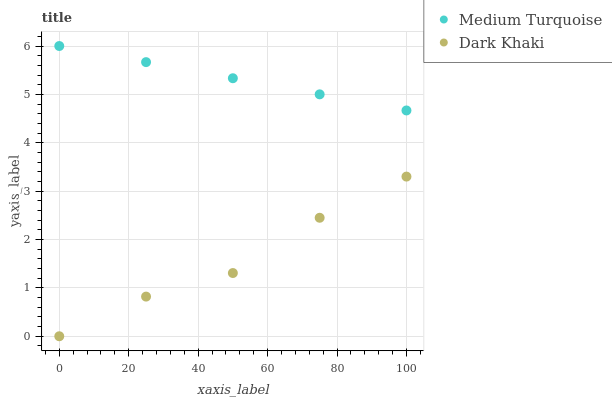Does Dark Khaki have the minimum area under the curve?
Answer yes or no. Yes. Does Medium Turquoise have the maximum area under the curve?
Answer yes or no. Yes. Does Medium Turquoise have the minimum area under the curve?
Answer yes or no. No. Is Medium Turquoise the smoothest?
Answer yes or no. Yes. Is Dark Khaki the roughest?
Answer yes or no. Yes. Is Medium Turquoise the roughest?
Answer yes or no. No. Does Dark Khaki have the lowest value?
Answer yes or no. Yes. Does Medium Turquoise have the lowest value?
Answer yes or no. No. Does Medium Turquoise have the highest value?
Answer yes or no. Yes. Is Dark Khaki less than Medium Turquoise?
Answer yes or no. Yes. Is Medium Turquoise greater than Dark Khaki?
Answer yes or no. Yes. Does Dark Khaki intersect Medium Turquoise?
Answer yes or no. No. 